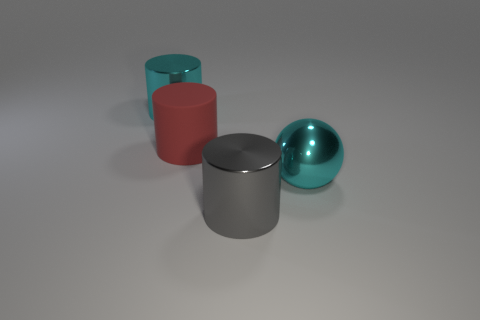Subtract all large rubber cylinders. How many cylinders are left? 2 Add 4 red matte objects. How many objects exist? 8 Subtract all red cylinders. How many cylinders are left? 2 Subtract 1 spheres. How many spheres are left? 0 Subtract all cylinders. How many objects are left? 1 Subtract 0 brown cylinders. How many objects are left? 4 Subtract all yellow spheres. Subtract all blue cubes. How many spheres are left? 1 Subtract all rubber cylinders. Subtract all gray rubber spheres. How many objects are left? 3 Add 4 gray metal things. How many gray metal things are left? 5 Add 4 large cyan shiny spheres. How many large cyan shiny spheres exist? 5 